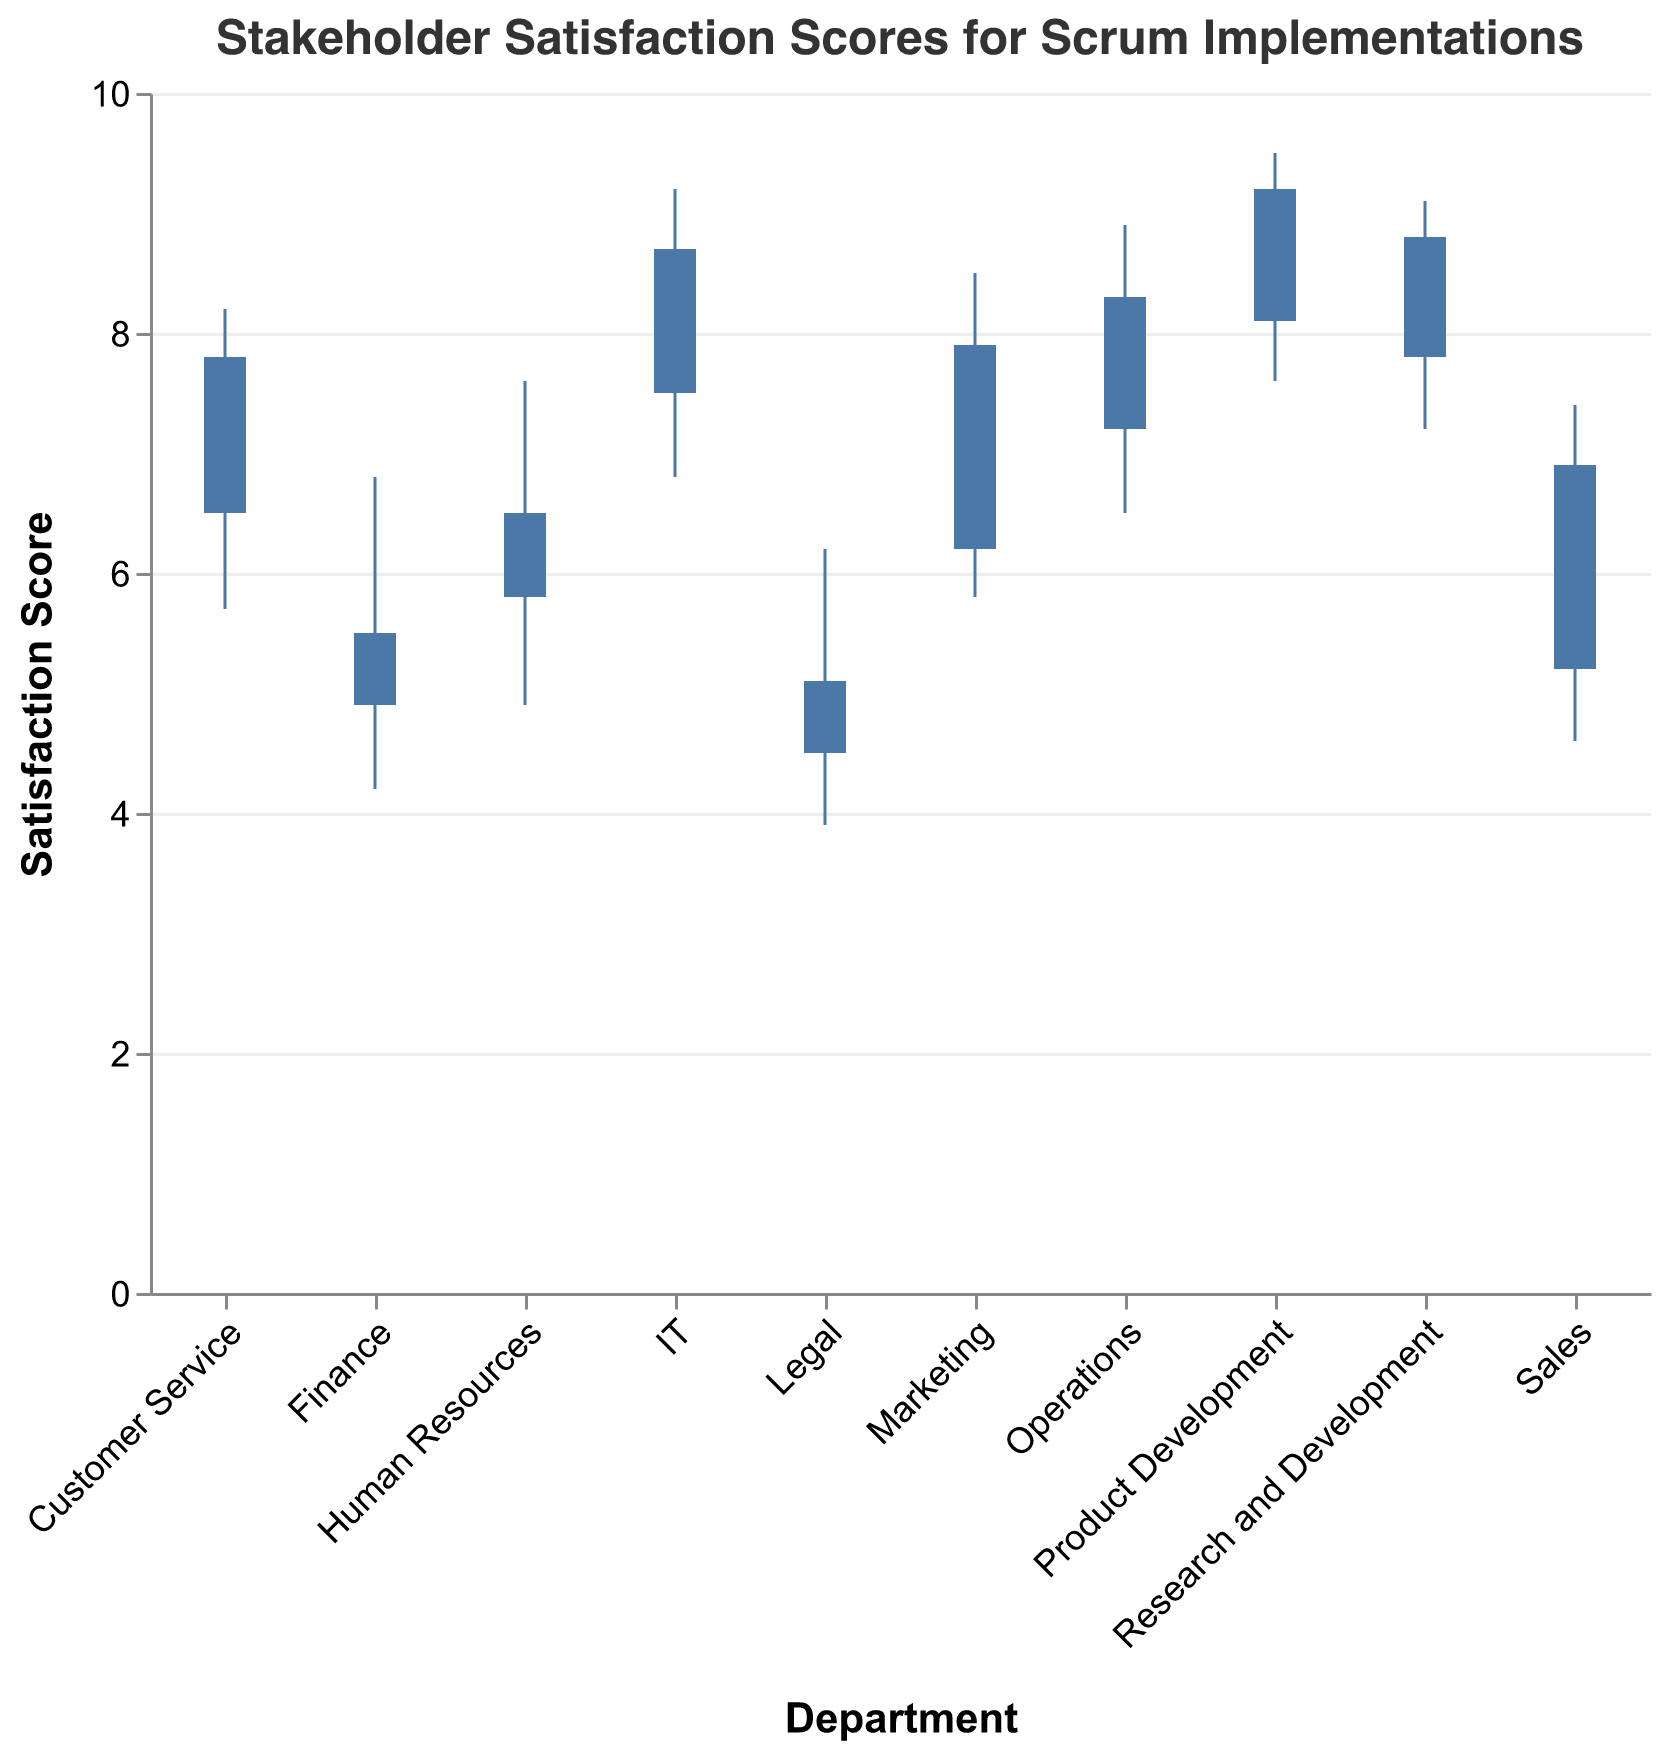What is the highest satisfaction score for the IT department? The "High" value for the IT department is 9.2, indicating the highest satisfaction score.
Answer: 9.2 Which department has the lowest "Open" satisfaction score? By examining the "Open" values across all departments, we see that the Legal department has the lowest "Open" score of 4.5.
Answer: Legal How does the "Close" score for Marketing compare to that of Sales? The "Close" score for Marketing is 7.9, while for Sales, it is 6.9. Therefore, the "Close" score for Marketing is higher.
Answer: Marketing's score is higher Which department has the most significant drop in satisfaction score from "Open" to "Low"? Calculate the difference between "Open" and "Low" for each department. Legal has the biggest drop of 4.5 - 3.9 = 0.6.
Answer: Legal What is the average satisfaction score "Close" across all departments? Sum up all the "Close" scores and divide by the number of departments: (7.9 + 8.7 + 6.5 + 5.5 + 9.2 + 7.8 + 6.9 + 8.3 + 8.8 + 5.1) / 10 = 7.47.
Answer: 7.47 How many departments have a "High" satisfaction score above 9.0? Departments with a "High" score above 9.0 are: IT, Product Development, and Research and Development (3 departments).
Answer: 3 Which department has the narrowest range between "Low" and "High" scores? Calculate "High" minus "Low" for each department. Research and Development has the narrowest range of 9.1 - 7.2 = 1.9.
Answer: Research and Development What is the range of "High" scores among all departments? Find the maximum "High" score (9.5) and the minimum "High" score (6.2), then subtract the minimum from the maximum: 9.5 - 6.2 = 3.3.
Answer: 3.3 Which department finishes with a higher "Close" score: Operations or Customer Service? The "Close" score for Operations is 8.3, while for Customer Service, it is 7.8. Therefore, Operations finishes with a higher "Close" score.
Answer: Operations 